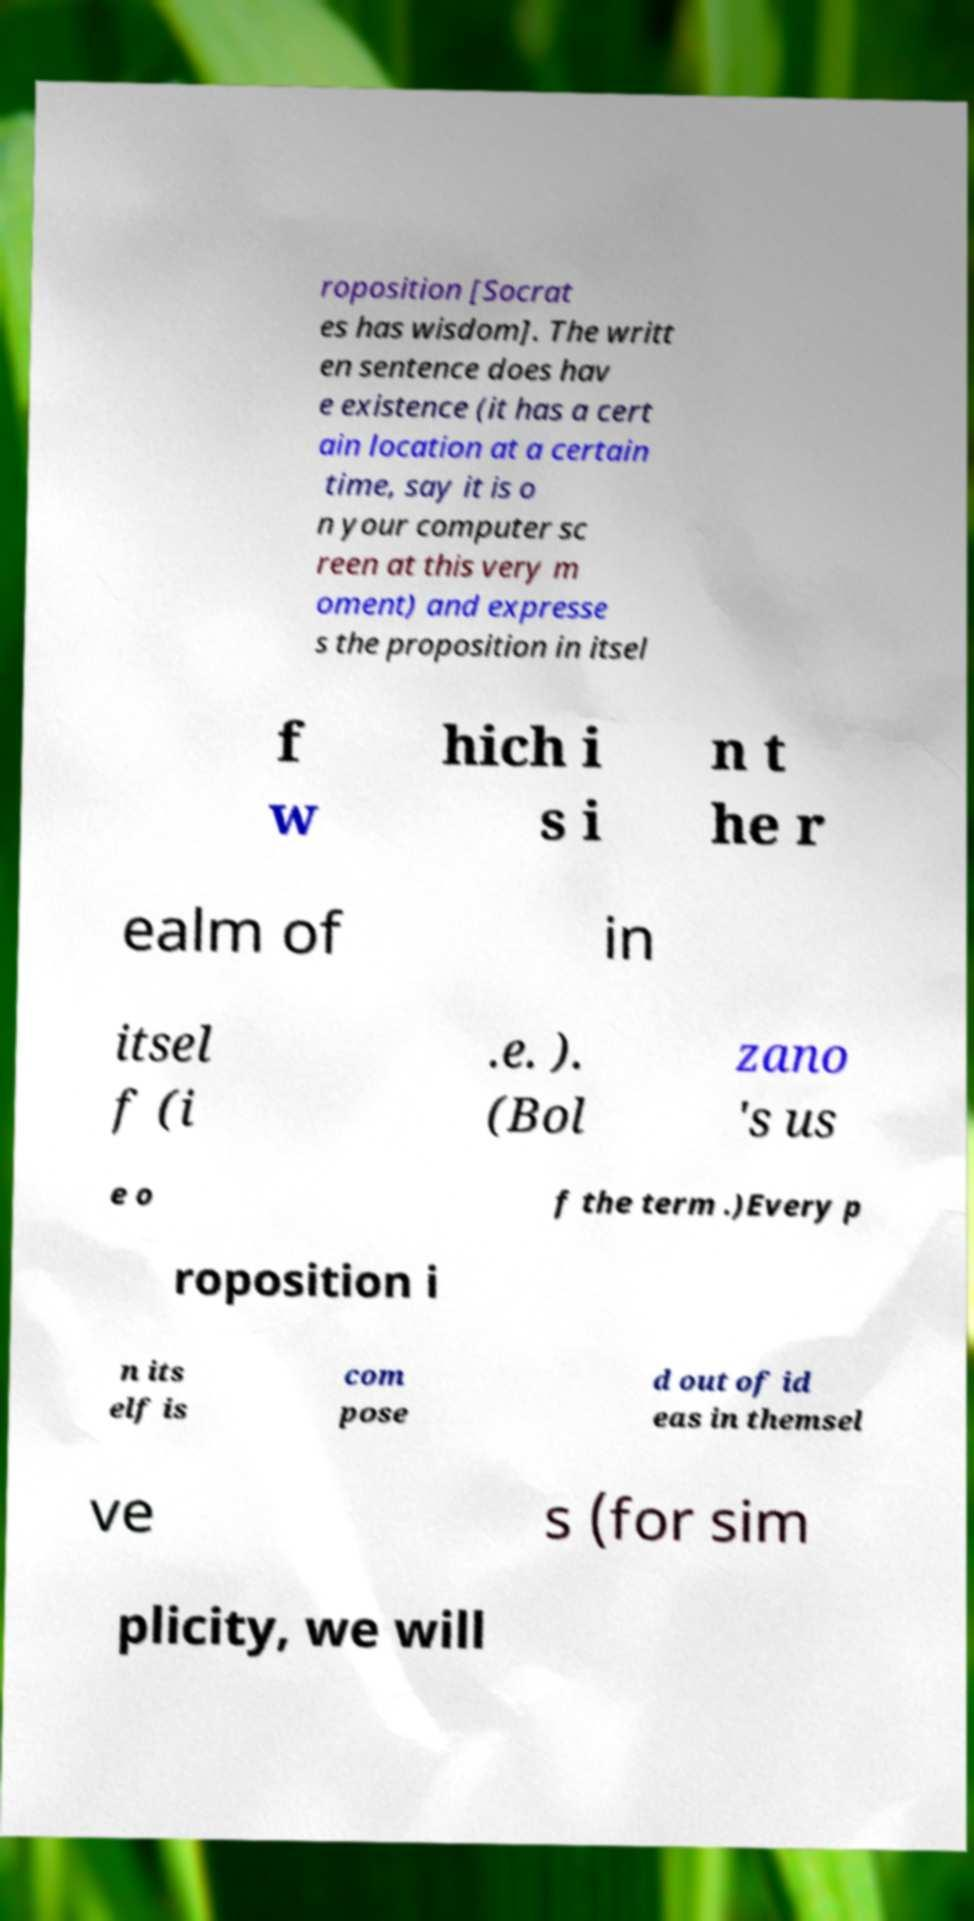I need the written content from this picture converted into text. Can you do that? roposition [Socrat es has wisdom]. The writt en sentence does hav e existence (it has a cert ain location at a certain time, say it is o n your computer sc reen at this very m oment) and expresse s the proposition in itsel f w hich i s i n t he r ealm of in itsel f (i .e. ). (Bol zano 's us e o f the term .)Every p roposition i n its elf is com pose d out of id eas in themsel ve s (for sim plicity, we will 